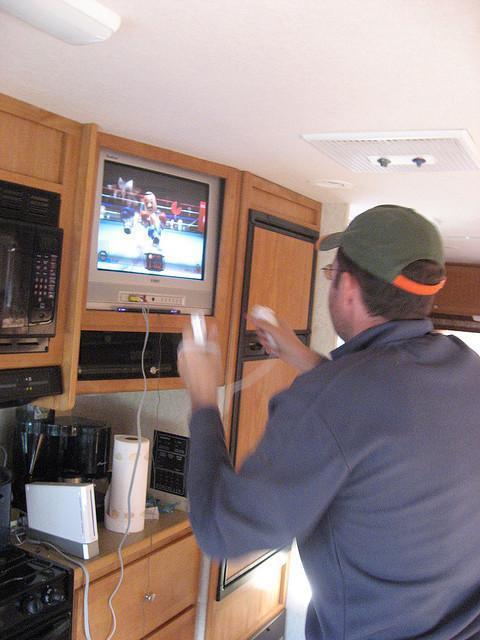How many ovens are in the picture?
Give a very brief answer. 1. How many red chairs are in this image?
Give a very brief answer. 0. 